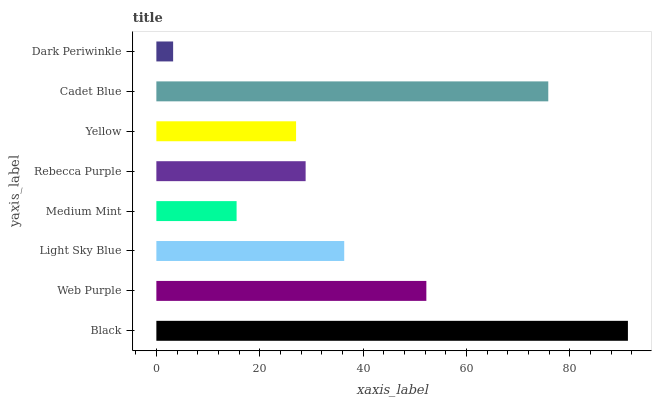Is Dark Periwinkle the minimum?
Answer yes or no. Yes. Is Black the maximum?
Answer yes or no. Yes. Is Web Purple the minimum?
Answer yes or no. No. Is Web Purple the maximum?
Answer yes or no. No. Is Black greater than Web Purple?
Answer yes or no. Yes. Is Web Purple less than Black?
Answer yes or no. Yes. Is Web Purple greater than Black?
Answer yes or no. No. Is Black less than Web Purple?
Answer yes or no. No. Is Light Sky Blue the high median?
Answer yes or no. Yes. Is Rebecca Purple the low median?
Answer yes or no. Yes. Is Dark Periwinkle the high median?
Answer yes or no. No. Is Cadet Blue the low median?
Answer yes or no. No. 